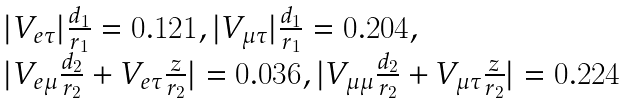Convert formula to latex. <formula><loc_0><loc_0><loc_500><loc_500>\begin{array} { l } | V _ { e \tau } | \frac { d _ { 1 } } { r _ { 1 } } = 0 . 1 2 1 , | V _ { \mu \tau } | \frac { d _ { 1 } } { r _ { 1 } } = 0 . 2 0 4 , \\ | V _ { e \mu } \frac { d _ { 2 } } { r _ { 2 } } + V _ { e \tau } \frac { z } { r _ { 2 } } | = 0 . 0 3 6 , | V _ { \mu \mu } \frac { d _ { 2 } } { r _ { 2 } } + V _ { \mu \tau } \frac { z } { r _ { 2 } } | = 0 . 2 2 4 \end{array}</formula> 